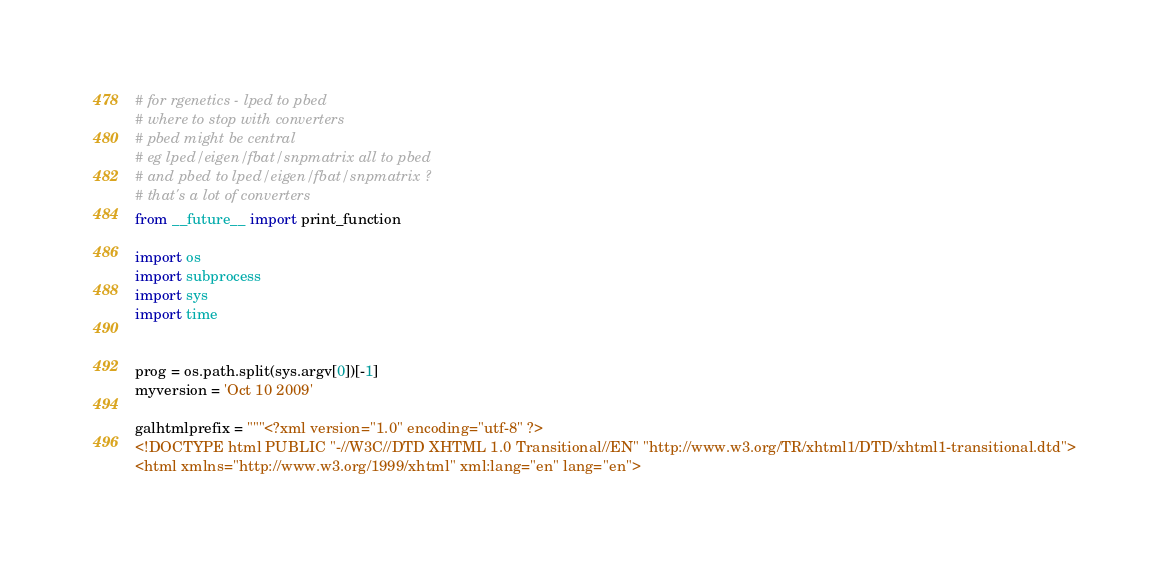<code> <loc_0><loc_0><loc_500><loc_500><_Python_># for rgenetics - lped to pbed
# where to stop with converters
# pbed might be central
# eg lped/eigen/fbat/snpmatrix all to pbed
# and pbed to lped/eigen/fbat/snpmatrix ?
# that's a lot of converters
from __future__ import print_function

import os
import subprocess
import sys
import time


prog = os.path.split(sys.argv[0])[-1]
myversion = 'Oct 10 2009'

galhtmlprefix = """<?xml version="1.0" encoding="utf-8" ?>
<!DOCTYPE html PUBLIC "-//W3C//DTD XHTML 1.0 Transitional//EN" "http://www.w3.org/TR/xhtml1/DTD/xhtml1-transitional.dtd">
<html xmlns="http://www.w3.org/1999/xhtml" xml:lang="en" lang="en"></code> 